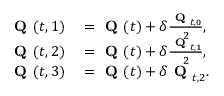Convert formula to latex. <formula><loc_0><loc_0><loc_500><loc_500>\begin{array} { r l } { Q ( t , { 1 } ) } & = Q ( t ) + \delta \frac { Q _ { t , 0 } } { 2 } , } \\ { Q ( t , { 2 } ) } & = Q ( t ) + \delta \frac { Q _ { t , 1 } } { 2 } , } \\ { Q ( t , { 3 } ) } & = Q ( t ) + \delta Q _ { t , 2 } . } \end{array}</formula> 